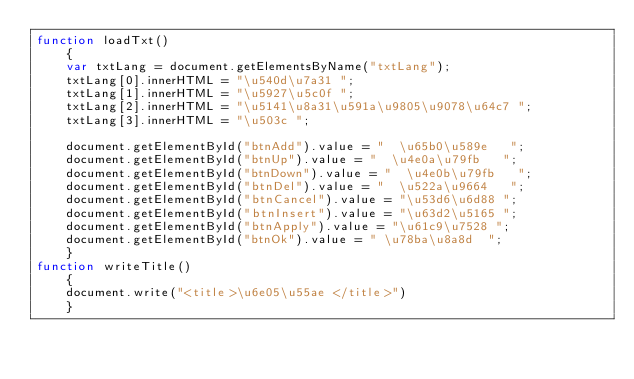<code> <loc_0><loc_0><loc_500><loc_500><_JavaScript_>function loadTxt()
    {
    var txtLang = document.getElementsByName("txtLang");
    txtLang[0].innerHTML = "\u540d\u7a31 ";
    txtLang[1].innerHTML = "\u5927\u5c0f ";
    txtLang[2].innerHTML = "\u5141\u8a31\u591a\u9805\u9078\u64c7 ";
    txtLang[3].innerHTML = "\u503c ";
    
    document.getElementById("btnAdd").value = "  \u65b0\u589e   ";
    document.getElementById("btnUp").value = "  \u4e0a\u79fb   ";
    document.getElementById("btnDown").value = "  \u4e0b\u79fb   ";
    document.getElementById("btnDel").value = "  \u522a\u9664   ";
    document.getElementById("btnCancel").value = "\u53d6\u6d88 ";
    document.getElementById("btnInsert").value = "\u63d2\u5165 ";
    document.getElementById("btnApply").value = "\u61c9\u7528 ";
    document.getElementById("btnOk").value = " \u78ba\u8a8d  ";
    }
function writeTitle()
    {
    document.write("<title>\u6e05\u55ae </title>")
    }</code> 